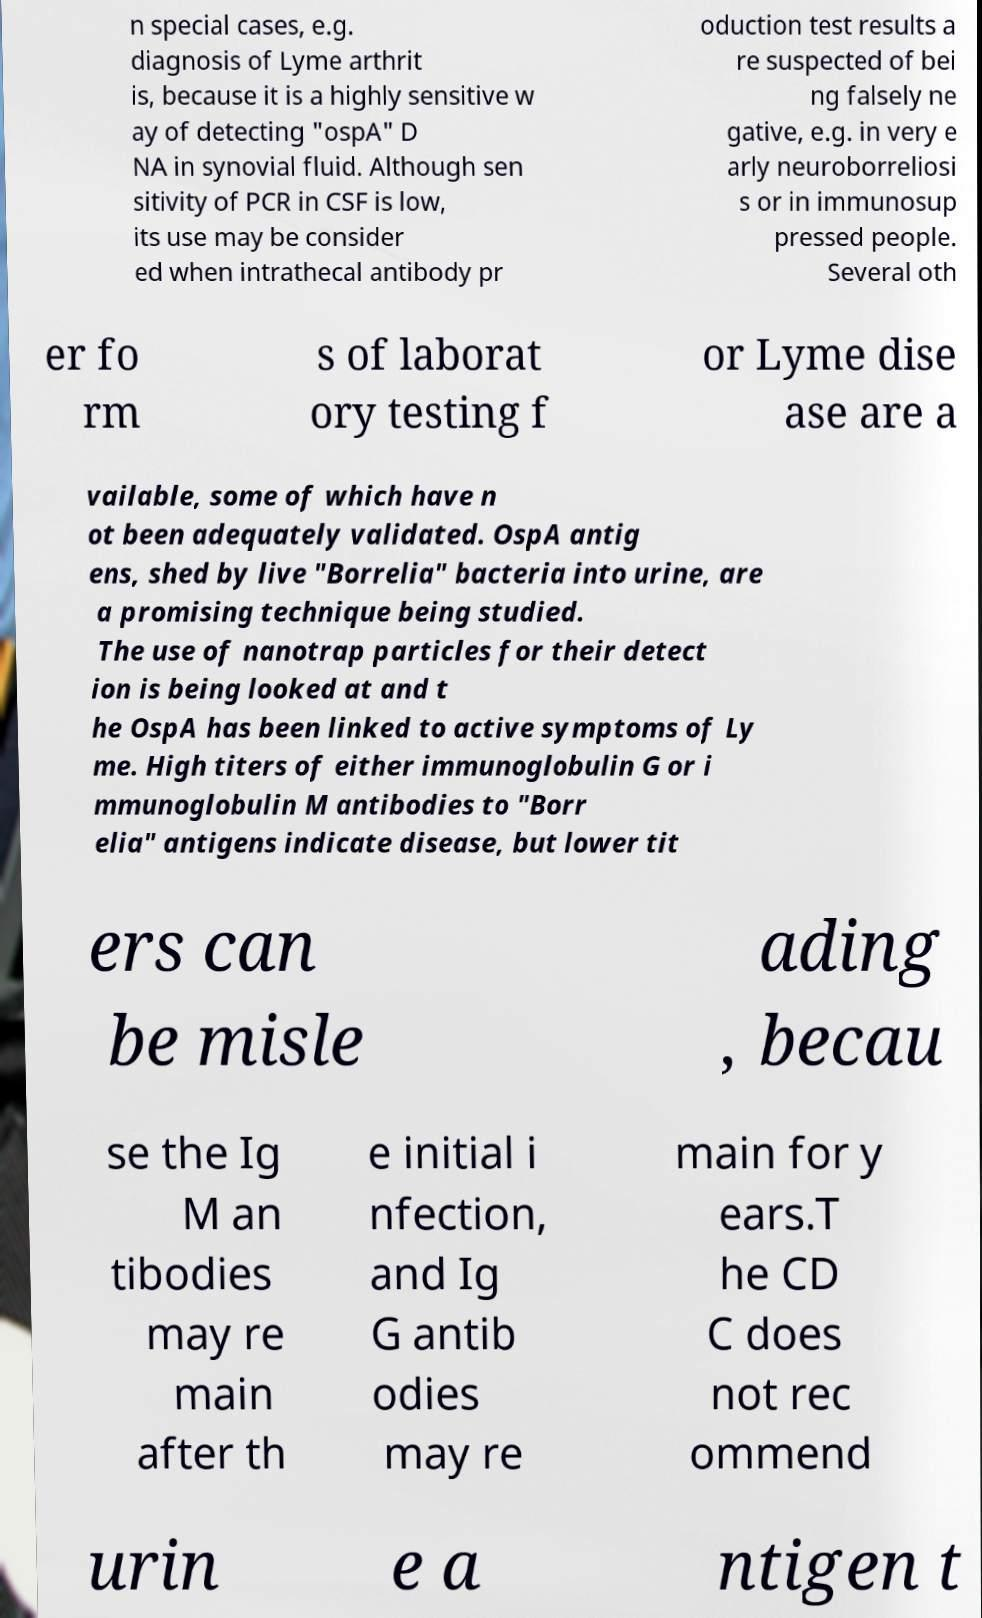Could you extract and type out the text from this image? n special cases, e.g. diagnosis of Lyme arthrit is, because it is a highly sensitive w ay of detecting "ospA" D NA in synovial fluid. Although sen sitivity of PCR in CSF is low, its use may be consider ed when intrathecal antibody pr oduction test results a re suspected of bei ng falsely ne gative, e.g. in very e arly neuroborreliosi s or in immunosup pressed people. Several oth er fo rm s of laborat ory testing f or Lyme dise ase are a vailable, some of which have n ot been adequately validated. OspA antig ens, shed by live "Borrelia" bacteria into urine, are a promising technique being studied. The use of nanotrap particles for their detect ion is being looked at and t he OspA has been linked to active symptoms of Ly me. High titers of either immunoglobulin G or i mmunoglobulin M antibodies to "Borr elia" antigens indicate disease, but lower tit ers can be misle ading , becau se the Ig M an tibodies may re main after th e initial i nfection, and Ig G antib odies may re main for y ears.T he CD C does not rec ommend urin e a ntigen t 